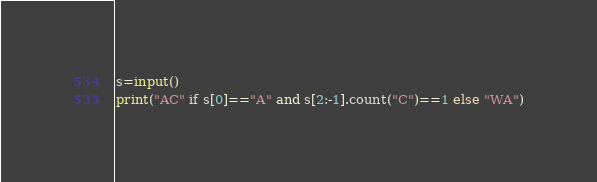<code> <loc_0><loc_0><loc_500><loc_500><_Python_>s=input()
print("AC" if s[0]=="A" and s[2:-1].count("C")==1 else "WA")</code> 